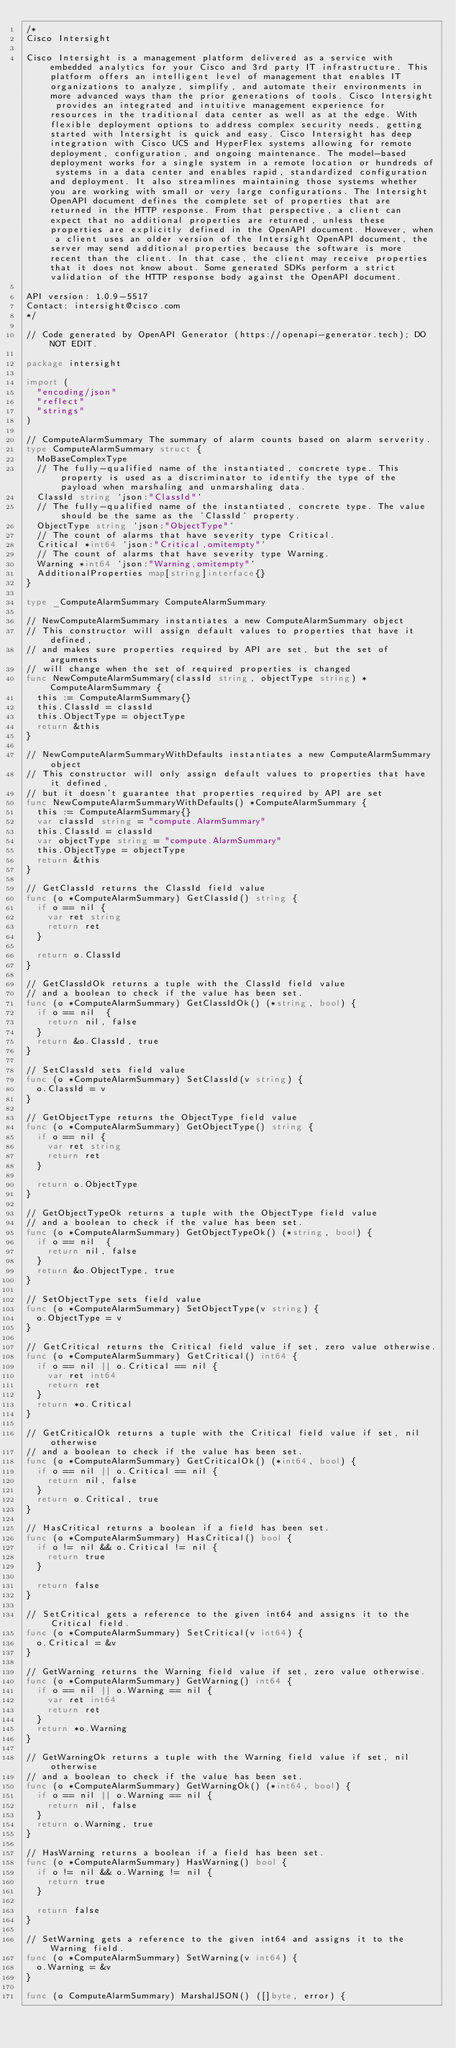<code> <loc_0><loc_0><loc_500><loc_500><_Go_>/*
Cisco Intersight

Cisco Intersight is a management platform delivered as a service with embedded analytics for your Cisco and 3rd party IT infrastructure. This platform offers an intelligent level of management that enables IT organizations to analyze, simplify, and automate their environments in more advanced ways than the prior generations of tools. Cisco Intersight provides an integrated and intuitive management experience for resources in the traditional data center as well as at the edge. With flexible deployment options to address complex security needs, getting started with Intersight is quick and easy. Cisco Intersight has deep integration with Cisco UCS and HyperFlex systems allowing for remote deployment, configuration, and ongoing maintenance. The model-based deployment works for a single system in a remote location or hundreds of systems in a data center and enables rapid, standardized configuration and deployment. It also streamlines maintaining those systems whether you are working with small or very large configurations. The Intersight OpenAPI document defines the complete set of properties that are returned in the HTTP response. From that perspective, a client can expect that no additional properties are returned, unless these properties are explicitly defined in the OpenAPI document. However, when a client uses an older version of the Intersight OpenAPI document, the server may send additional properties because the software is more recent than the client. In that case, the client may receive properties that it does not know about. Some generated SDKs perform a strict validation of the HTTP response body against the OpenAPI document.

API version: 1.0.9-5517
Contact: intersight@cisco.com
*/

// Code generated by OpenAPI Generator (https://openapi-generator.tech); DO NOT EDIT.

package intersight

import (
	"encoding/json"
	"reflect"
	"strings"
)

// ComputeAlarmSummary The summary of alarm counts based on alarm serverity.
type ComputeAlarmSummary struct {
	MoBaseComplexType
	// The fully-qualified name of the instantiated, concrete type. This property is used as a discriminator to identify the type of the payload when marshaling and unmarshaling data.
	ClassId string `json:"ClassId"`
	// The fully-qualified name of the instantiated, concrete type. The value should be the same as the 'ClassId' property.
	ObjectType string `json:"ObjectType"`
	// The count of alarms that have severity type Critical.
	Critical *int64 `json:"Critical,omitempty"`
	// The count of alarms that have severity type Warning.
	Warning *int64 `json:"Warning,omitempty"`
	AdditionalProperties map[string]interface{}
}

type _ComputeAlarmSummary ComputeAlarmSummary

// NewComputeAlarmSummary instantiates a new ComputeAlarmSummary object
// This constructor will assign default values to properties that have it defined,
// and makes sure properties required by API are set, but the set of arguments
// will change when the set of required properties is changed
func NewComputeAlarmSummary(classId string, objectType string) *ComputeAlarmSummary {
	this := ComputeAlarmSummary{}
	this.ClassId = classId
	this.ObjectType = objectType
	return &this
}

// NewComputeAlarmSummaryWithDefaults instantiates a new ComputeAlarmSummary object
// This constructor will only assign default values to properties that have it defined,
// but it doesn't guarantee that properties required by API are set
func NewComputeAlarmSummaryWithDefaults() *ComputeAlarmSummary {
	this := ComputeAlarmSummary{}
	var classId string = "compute.AlarmSummary"
	this.ClassId = classId
	var objectType string = "compute.AlarmSummary"
	this.ObjectType = objectType
	return &this
}

// GetClassId returns the ClassId field value
func (o *ComputeAlarmSummary) GetClassId() string {
	if o == nil {
		var ret string
		return ret
	}

	return o.ClassId
}

// GetClassIdOk returns a tuple with the ClassId field value
// and a boolean to check if the value has been set.
func (o *ComputeAlarmSummary) GetClassIdOk() (*string, bool) {
	if o == nil  {
		return nil, false
	}
	return &o.ClassId, true
}

// SetClassId sets field value
func (o *ComputeAlarmSummary) SetClassId(v string) {
	o.ClassId = v
}

// GetObjectType returns the ObjectType field value
func (o *ComputeAlarmSummary) GetObjectType() string {
	if o == nil {
		var ret string
		return ret
	}

	return o.ObjectType
}

// GetObjectTypeOk returns a tuple with the ObjectType field value
// and a boolean to check if the value has been set.
func (o *ComputeAlarmSummary) GetObjectTypeOk() (*string, bool) {
	if o == nil  {
		return nil, false
	}
	return &o.ObjectType, true
}

// SetObjectType sets field value
func (o *ComputeAlarmSummary) SetObjectType(v string) {
	o.ObjectType = v
}

// GetCritical returns the Critical field value if set, zero value otherwise.
func (o *ComputeAlarmSummary) GetCritical() int64 {
	if o == nil || o.Critical == nil {
		var ret int64
		return ret
	}
	return *o.Critical
}

// GetCriticalOk returns a tuple with the Critical field value if set, nil otherwise
// and a boolean to check if the value has been set.
func (o *ComputeAlarmSummary) GetCriticalOk() (*int64, bool) {
	if o == nil || o.Critical == nil {
		return nil, false
	}
	return o.Critical, true
}

// HasCritical returns a boolean if a field has been set.
func (o *ComputeAlarmSummary) HasCritical() bool {
	if o != nil && o.Critical != nil {
		return true
	}

	return false
}

// SetCritical gets a reference to the given int64 and assigns it to the Critical field.
func (o *ComputeAlarmSummary) SetCritical(v int64) {
	o.Critical = &v
}

// GetWarning returns the Warning field value if set, zero value otherwise.
func (o *ComputeAlarmSummary) GetWarning() int64 {
	if o == nil || o.Warning == nil {
		var ret int64
		return ret
	}
	return *o.Warning
}

// GetWarningOk returns a tuple with the Warning field value if set, nil otherwise
// and a boolean to check if the value has been set.
func (o *ComputeAlarmSummary) GetWarningOk() (*int64, bool) {
	if o == nil || o.Warning == nil {
		return nil, false
	}
	return o.Warning, true
}

// HasWarning returns a boolean if a field has been set.
func (o *ComputeAlarmSummary) HasWarning() bool {
	if o != nil && o.Warning != nil {
		return true
	}

	return false
}

// SetWarning gets a reference to the given int64 and assigns it to the Warning field.
func (o *ComputeAlarmSummary) SetWarning(v int64) {
	o.Warning = &v
}

func (o ComputeAlarmSummary) MarshalJSON() ([]byte, error) {</code> 